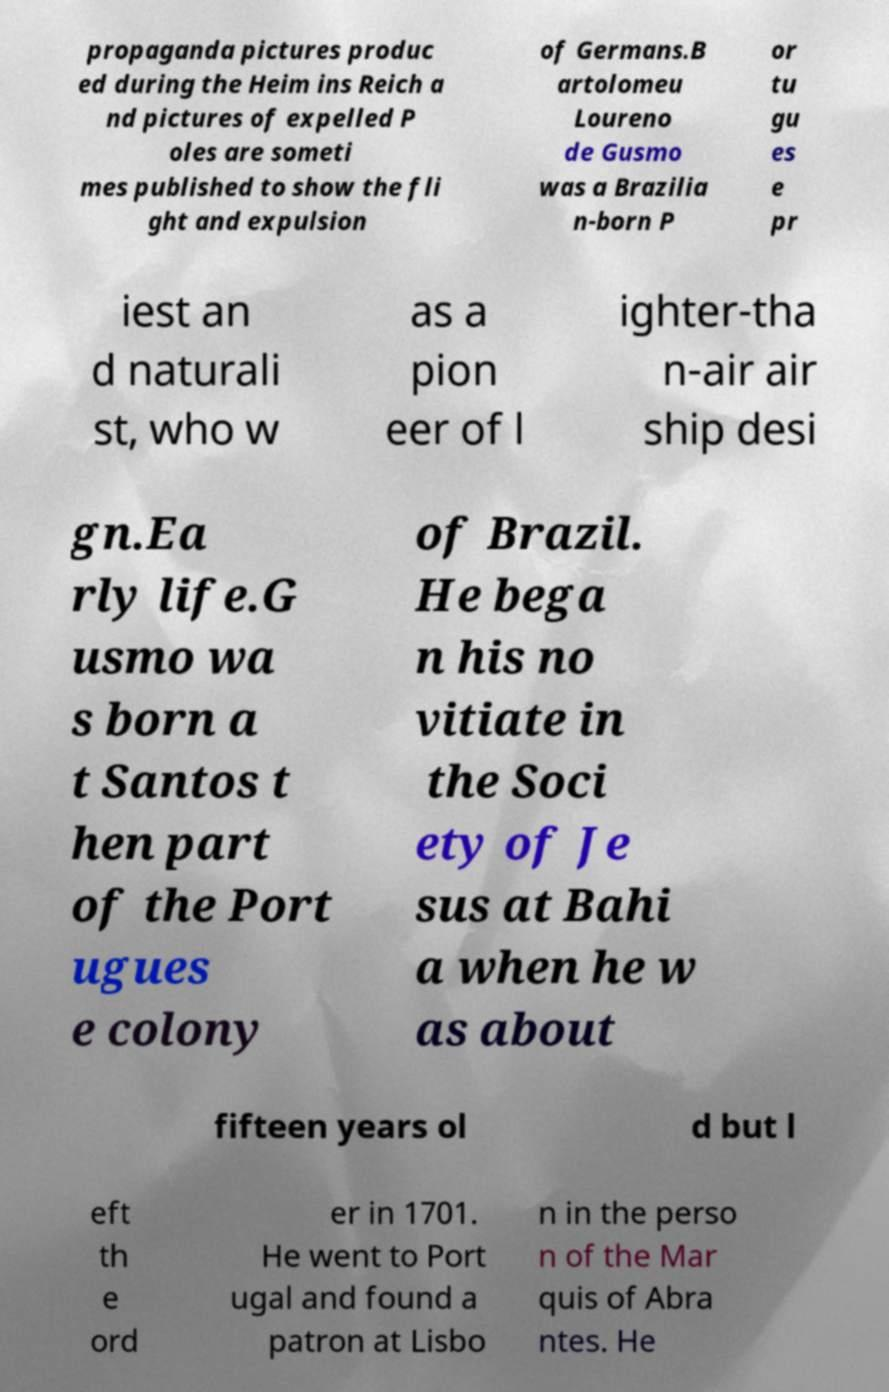What messages or text are displayed in this image? I need them in a readable, typed format. propaganda pictures produc ed during the Heim ins Reich a nd pictures of expelled P oles are someti mes published to show the fli ght and expulsion of Germans.B artolomeu Loureno de Gusmo was a Brazilia n-born P or tu gu es e pr iest an d naturali st, who w as a pion eer of l ighter-tha n-air air ship desi gn.Ea rly life.G usmo wa s born a t Santos t hen part of the Port ugues e colony of Brazil. He bega n his no vitiate in the Soci ety of Je sus at Bahi a when he w as about fifteen years ol d but l eft th e ord er in 1701. He went to Port ugal and found a patron at Lisbo n in the perso n of the Mar quis of Abra ntes. He 